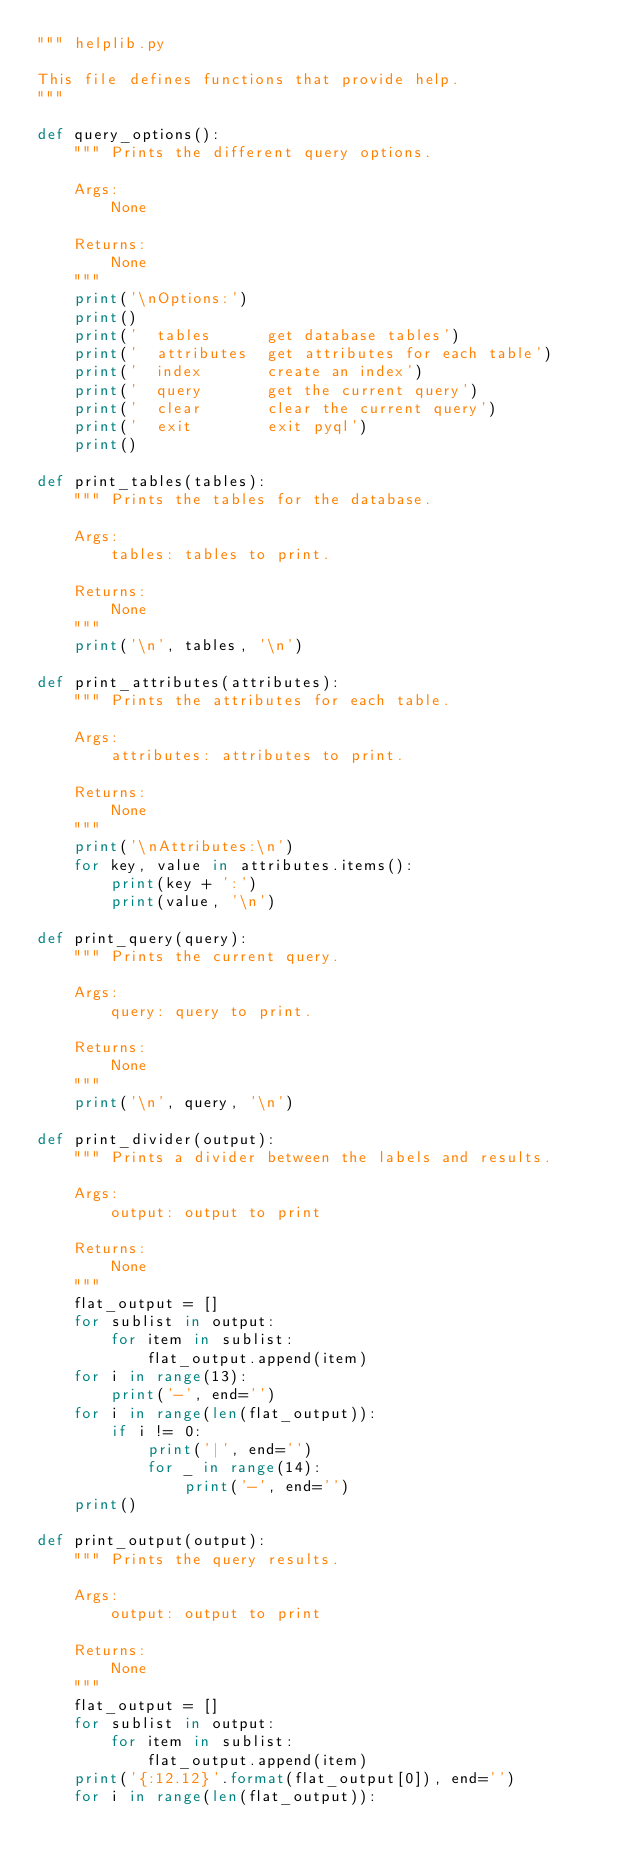Convert code to text. <code><loc_0><loc_0><loc_500><loc_500><_Python_>""" helplib.py

This file defines functions that provide help.
"""

def query_options():
    """ Prints the different query options.

    Args:
        None

    Returns:
        None
    """
    print('\nOptions:')
    print()
    print('  tables      get database tables')
    print('  attributes  get attributes for each table')
    print('  index       create an index')
    print('  query       get the current query')
    print('  clear       clear the current query')
    print('  exit        exit pyql')
    print()

def print_tables(tables):
    """ Prints the tables for the database.

    Args:
        tables: tables to print.

    Returns:
        None
    """
    print('\n', tables, '\n')

def print_attributes(attributes):
    """ Prints the attributes for each table.

    Args:
        attributes: attributes to print.

    Returns:
        None
    """
    print('\nAttributes:\n')
    for key, value in attributes.items():
        print(key + ':')
        print(value, '\n')

def print_query(query):
    """ Prints the current query.

    Args:
        query: query to print.

    Returns:
        None
    """
    print('\n', query, '\n')

def print_divider(output):
    """ Prints a divider between the labels and results.

    Args:
        output: output to print

    Returns:
        None
    """
    flat_output = []
    for sublist in output:
        for item in sublist:
            flat_output.append(item)
    for i in range(13):
        print('-', end='')
    for i in range(len(flat_output)):
        if i != 0:
            print('|', end='')
            for _ in range(14):
                print('-', end='')
    print()

def print_output(output):
    """ Prints the query results.

    Args:
        output: output to print

    Returns:
        None
    """
    flat_output = []
    for sublist in output:
        for item in sublist:
            flat_output.append(item)
    print('{:12.12}'.format(flat_output[0]), end='')
    for i in range(len(flat_output)):</code> 